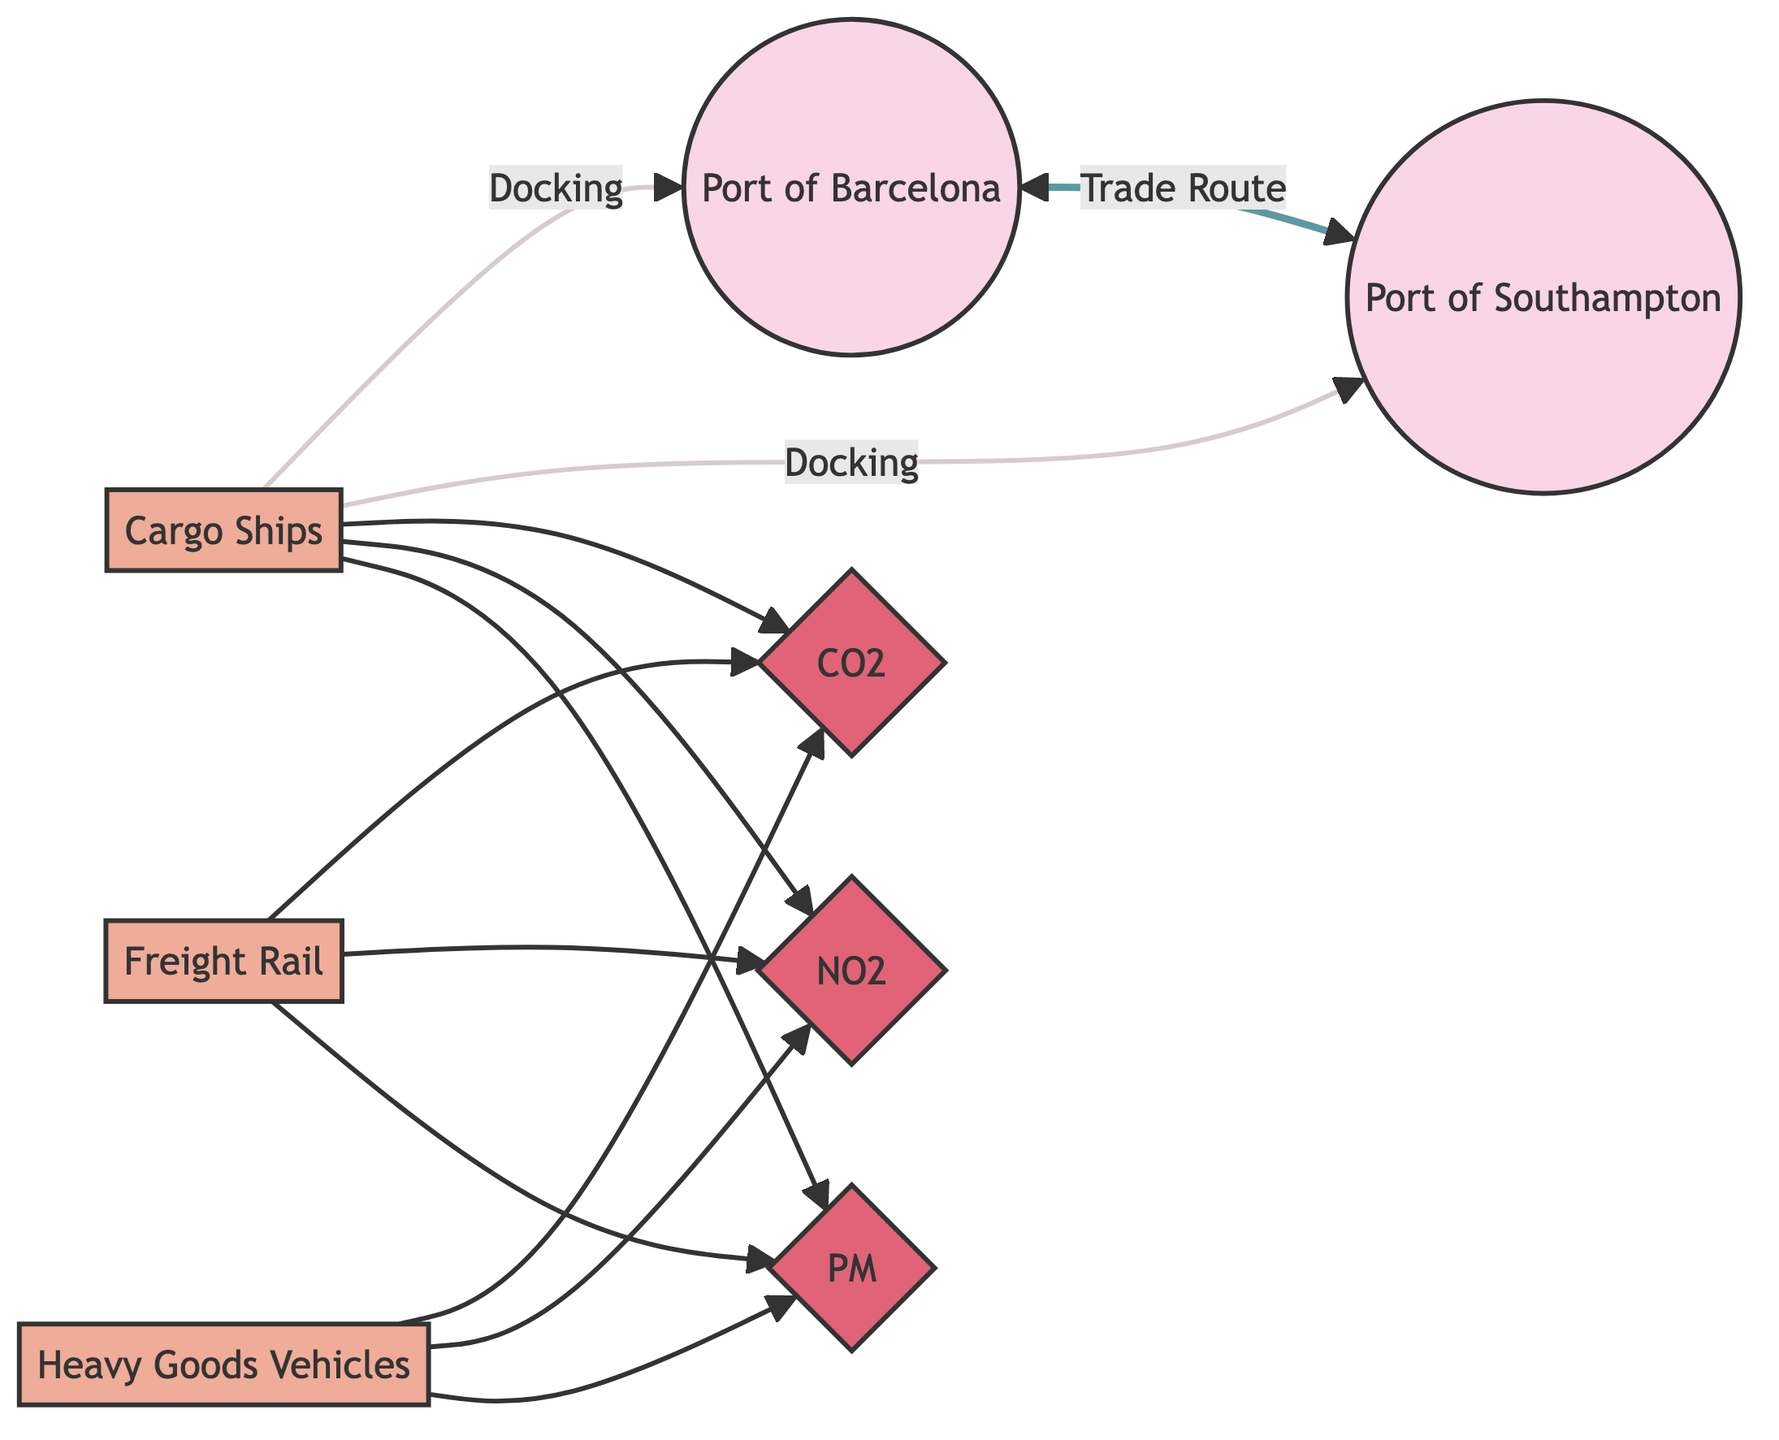What are the two ports involved in the trade route? The diagram shows the two locations involved in the trade route; they are connected by the trade route line. The identified ports are the Port of Barcelona and the Port of Southampton.
Answer: Port of Barcelona, Port of Southampton How many transportation modes are depicted in the diagram? The diagram includes three transportation modes represented by nodes. These modes are cargo ships, freight rail, and heavy goods vehicles. Counting these nodes gives a total of three transportation modes.
Answer: 3 Which pollutant emissions are associated with cargo ships? The cargo ships node connects to three pollutants indicated in the diagram. Therefore, the pollutants associated with cargo ships are CO2, NO2, and PM.
Answer: CO2, NO2, PM What transportation mode has the least emissions connection? All three transportation modes in the diagram (cargo ships, freight rail, and HGV trucks) are connected to the same three pollutants. Thus, there is no transportation mode with fewer connections; all have three.
Answer: None What pollutant is emitted by heavy goods vehicles (HGV trucks)? The heavy goods vehicles node connects to the pollutants in the diagram. Thus, HGV trucks emit CO2, NO2, and PM.
Answer: CO2, NO2, PM Describe the relationship between the Port of Barcelona and the Port of Southampton? The two ports are connected directly through a trade route, indicating they have an active trade relationship.
Answer: Trade Route Which transportation mode has direct docking at both ports? The diagram indicates that cargo ships have docking connections to both the Port of Barcelona and the Port of Southampton. This implies cargo ships are directly involved with both ports.
Answer: Cargo Ships Identify the pollutants emitted by freight rail. The freight rail node has connections to three pollutants in the diagram. Therefore, it emits CO2, NO2, and PM.
Answer: CO2, NO2, PM What color represents the pollutant nodes in the diagram? The pollutant nodes in the diagram are styled based on a specific class defined within the diagram. They are colored in a shade of red, distinguishing them from other node types.
Answer: Red 